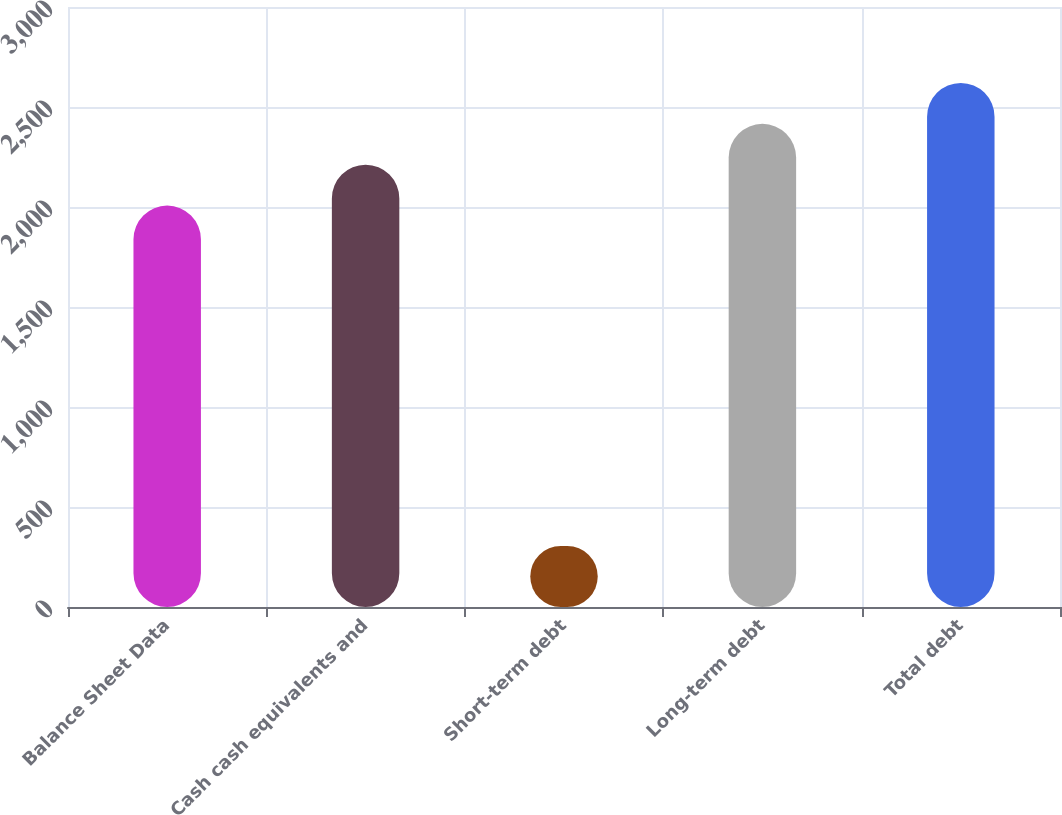Convert chart. <chart><loc_0><loc_0><loc_500><loc_500><bar_chart><fcel>Balance Sheet Data<fcel>Cash cash equivalents and<fcel>Short-term debt<fcel>Long-term debt<fcel>Total debt<nl><fcel>2007<fcel>2211.41<fcel>305.1<fcel>2415.82<fcel>2620.23<nl></chart> 